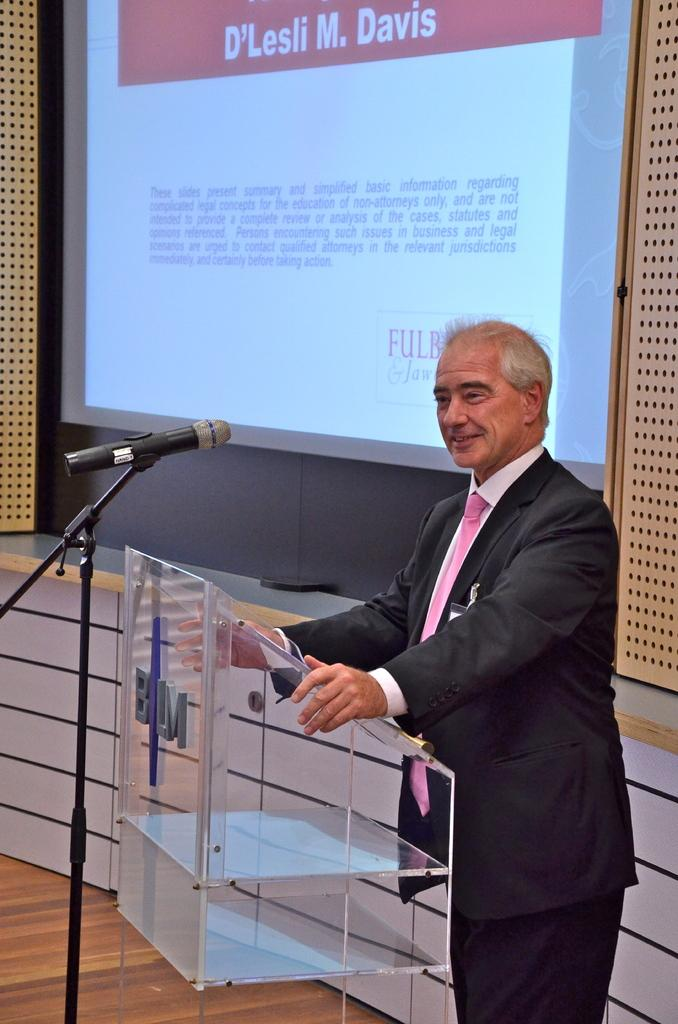What is the person in the image doing? The person is standing in front of a podium. What is on the podium? There is a microphone on the podium. What can be seen in the background of the image? There is a wall in the background of the image, and on the wall, there is a screen. What is displayed on the screen? Text is visible on the screen. How are the cats distributing the existence of the podium in the image? There are no cats present in the image, and therefore, they cannot distribute the existence of the podium. 